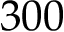<formula> <loc_0><loc_0><loc_500><loc_500>3 0 0</formula> 